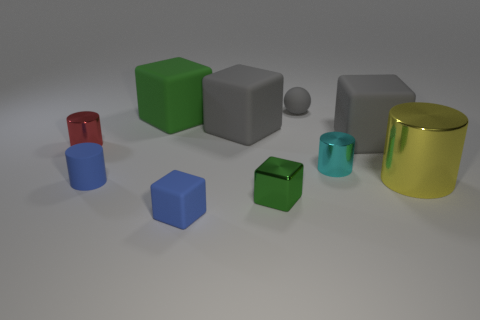How many metallic cylinders are there?
Offer a very short reply. 3. Does the tiny metal thing that is in front of the yellow cylinder have the same color as the tiny cylinder left of the small blue cylinder?
Your answer should be compact. No. There is a tiny blue cube; what number of large green blocks are in front of it?
Offer a very short reply. 0. There is a cube that is the same color as the small rubber cylinder; what material is it?
Ensure brevity in your answer.  Rubber. Are there any tiny blue rubber things of the same shape as the yellow metallic thing?
Your answer should be compact. Yes. Is the material of the large gray thing that is right of the cyan cylinder the same as the gray object that is to the left of the gray sphere?
Offer a terse response. Yes. There is a thing that is in front of the green object on the right side of the blue thing that is right of the tiny rubber cylinder; how big is it?
Ensure brevity in your answer.  Small. What material is the sphere that is the same size as the blue block?
Your answer should be very brief. Rubber. Are there any metallic cubes of the same size as the blue cylinder?
Make the answer very short. Yes. Is the shape of the yellow shiny object the same as the small red shiny object?
Offer a very short reply. Yes. 